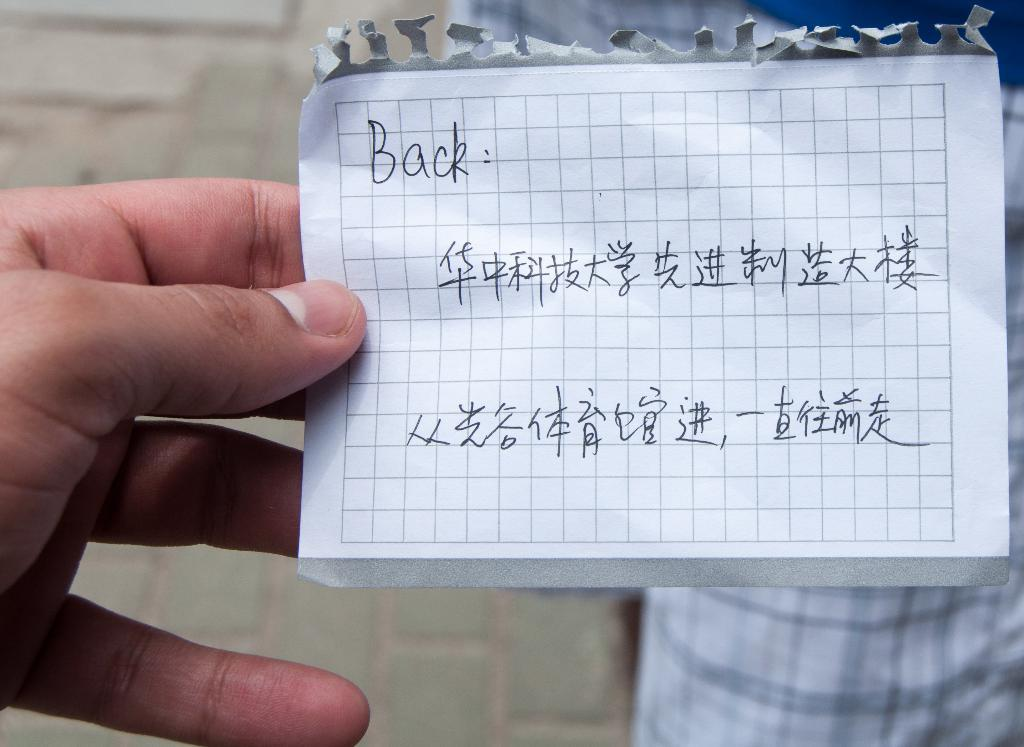What is present in the image? There is a person in the image. What is the person holding? The person is holding a paper. What type of rhythm is the person playing on the mitten in the image? There is no mitten or rhythm present in the image; it only features a person holding a paper. 